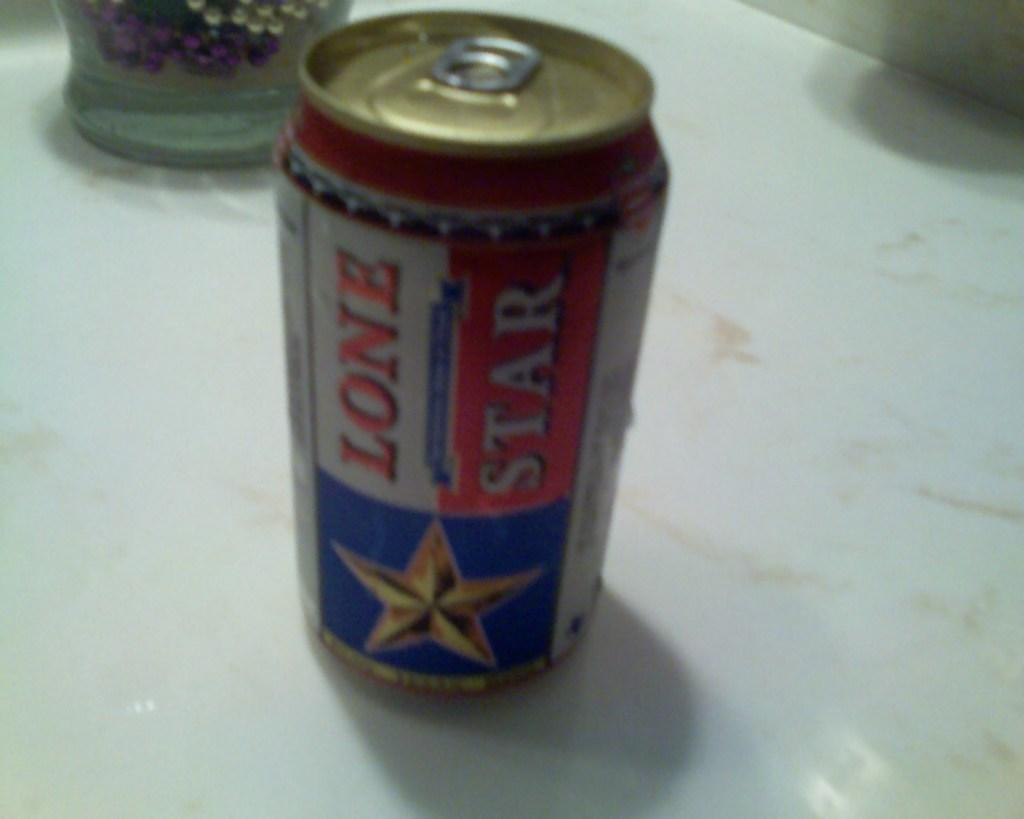<image>
Summarize the visual content of the image. can of lone star beer and the bottom of a glass in the background 